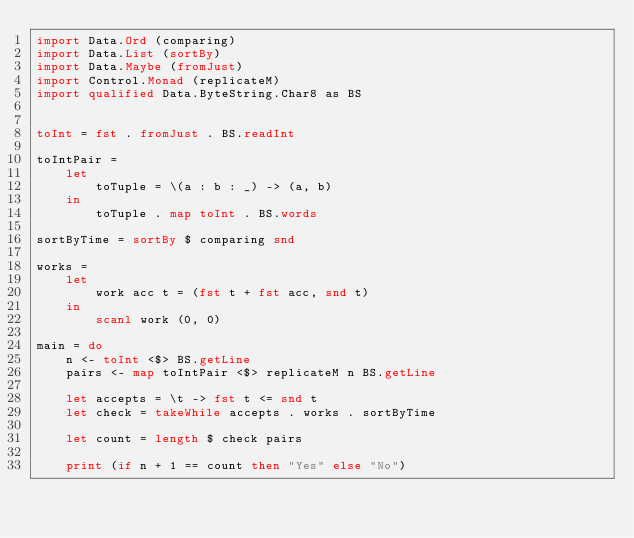<code> <loc_0><loc_0><loc_500><loc_500><_Haskell_>import Data.Ord (comparing)
import Data.List (sortBy)
import Data.Maybe (fromJust)
import Control.Monad (replicateM)
import qualified Data.ByteString.Char8 as BS


toInt = fst . fromJust . BS.readInt

toIntPair =
    let
        toTuple = \(a : b : _) -> (a, b)
    in
        toTuple . map toInt . BS.words

sortByTime = sortBy $ comparing snd

works =
    let
        work acc t = (fst t + fst acc, snd t)
    in
        scanl work (0, 0)

main = do
    n <- toInt <$> BS.getLine
    pairs <- map toIntPair <$> replicateM n BS.getLine

    let accepts = \t -> fst t <= snd t
    let check = takeWhile accepts . works . sortByTime

    let count = length $ check pairs

    print (if n + 1 == count then "Yes" else "No")</code> 